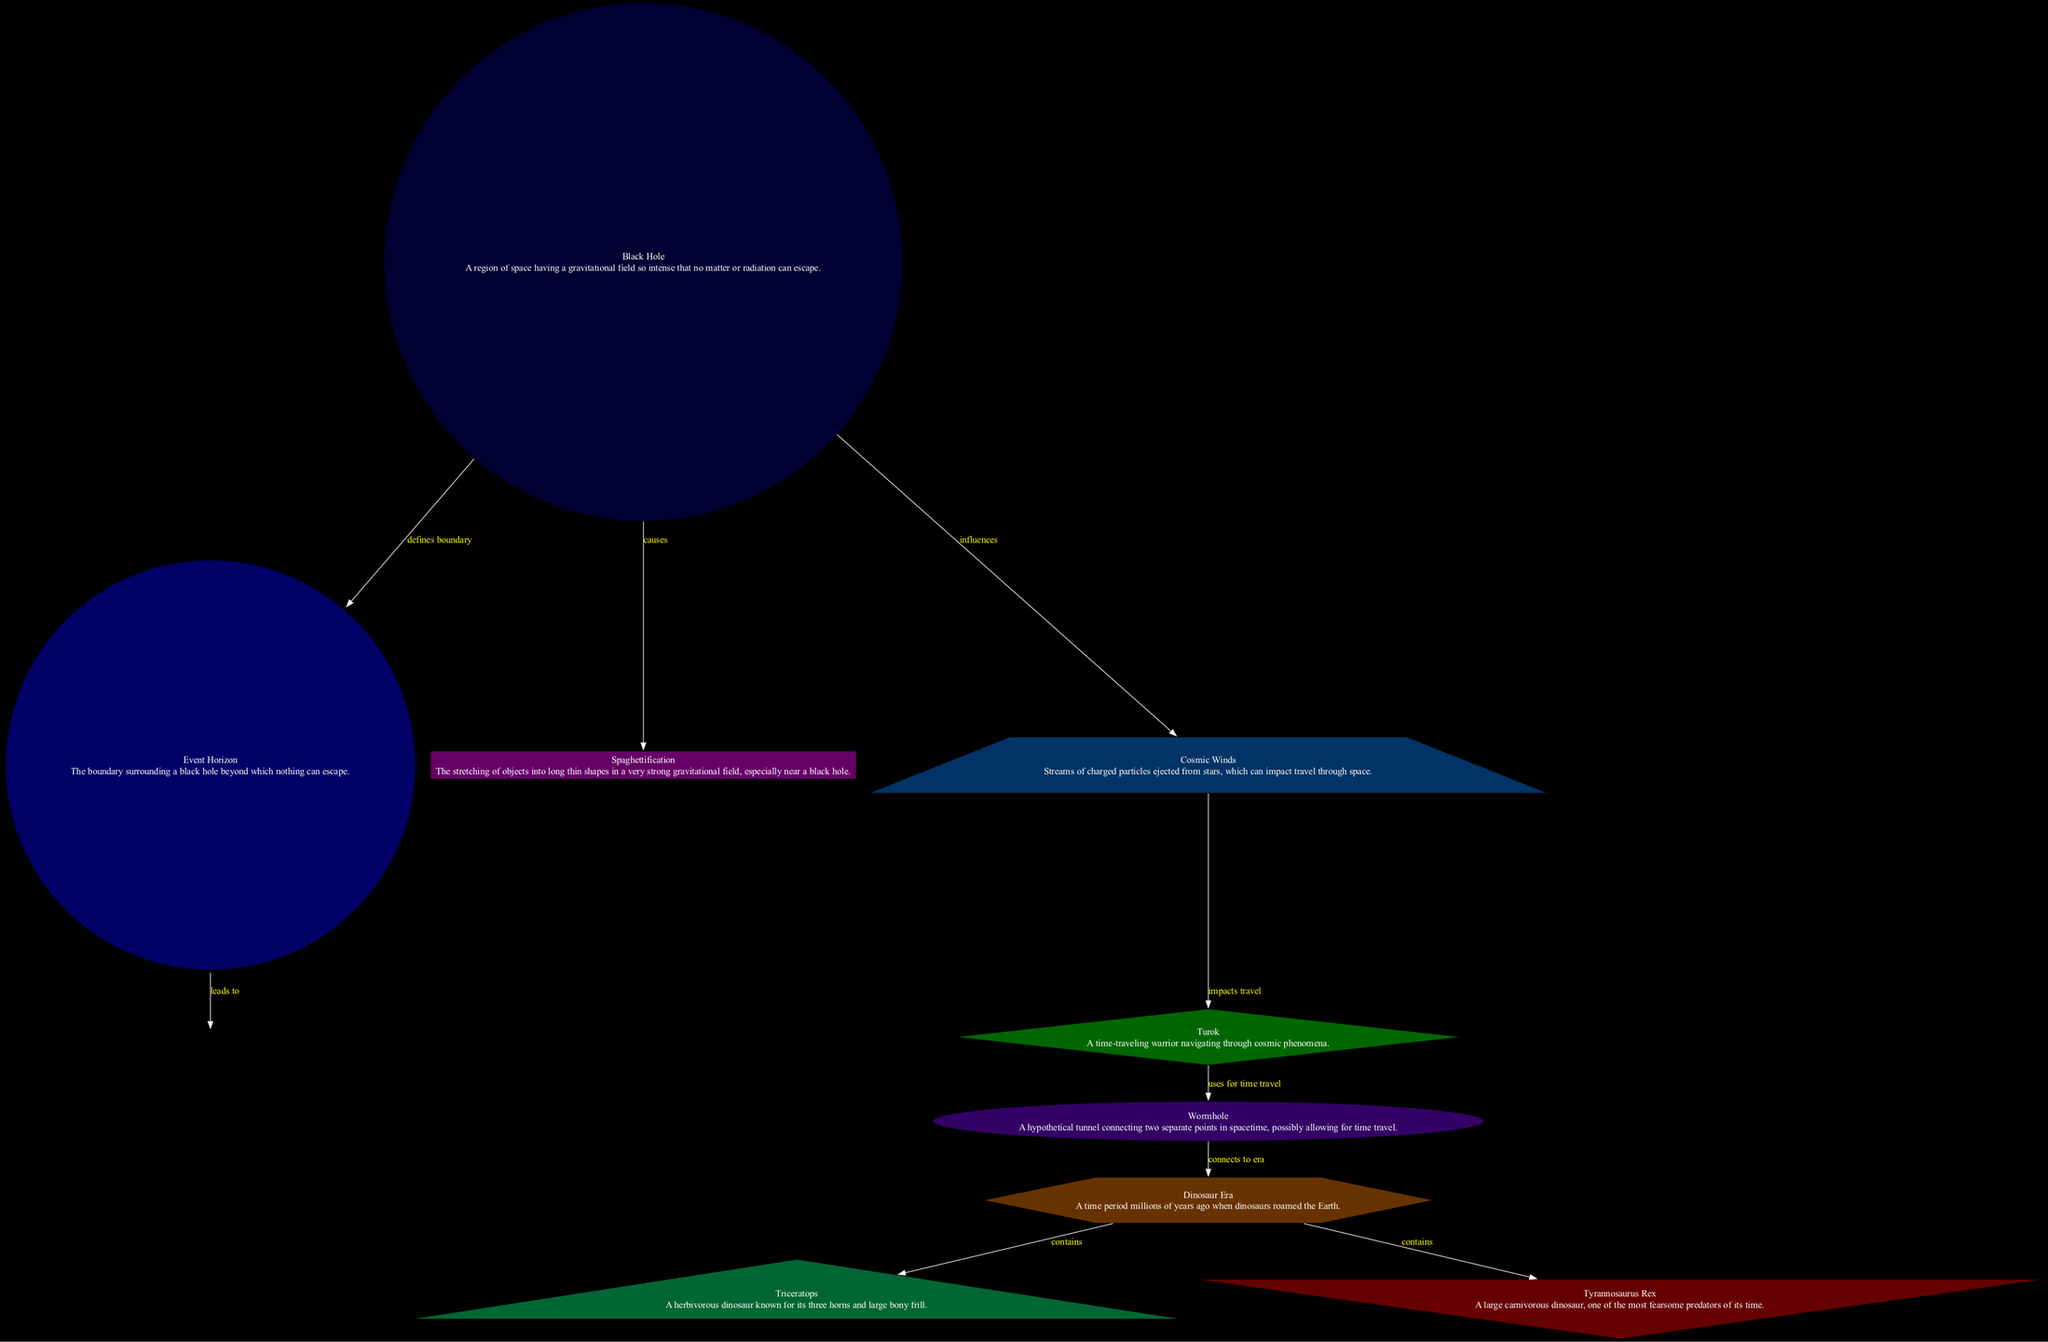What is the boundary surrounding a black hole called? The diagram indicates that the boundary surrounding a black hole is referred to as the "Event Horizon." This is the first piece of information associated with the black hole node in the diagram.
Answer: Event Horizon What dinosaur is known for its three horns? According to the diagram, the "Triceratops" is identified as a herbivorous dinosaur known for its three horns. This description is directly provided under the triceratops node.
Answer: Triceratops How many nodes are there in the diagram? The diagram contains a total of 10 nodes listed under the nodes section: black hole, event horizon, singularity, spaghettification, turok, wormhole, dinosaur era, triceratops, tyrannosaurus rex, and cosmic winds. Counting these gives us the total of 10 nodes.
Answer: 10 What effect does a black hole have on objects approaching it? The diagram states that a black hole causes "spaghettification," which is the stretching of objects into long thin shapes in a strong gravitational field. This relationship is specifically stated in the edge leading from black hole to spaghettification.
Answer: Spaghettification What connects Turok to the Dinosaur Era? The diagram shows that the "wormhole" connects Turok to the Dinosaur Era. This connection is highlighted as a direct relationship between the two nodes in the diagram.
Answer: Wormhole Which dinosaur is described as a large carnivorous predator? The diagram specifies that the "Tyrannosaurus Rex" is a large carnivorous dinosaur, known for being one of the most fearsome predators during the Dinosaur Era. This information is presented under the tyrannosaurus rex node.
Answer: Tyrannosaurus Rex How do cosmic winds impact Turok? The diagram indicates that "cosmic winds" impact Turok's travel. The edge connecting cosmic winds to Turok is labeled as "impacts travel," thus directly linking these two elements.
Answer: Impacts travel What is the point of infinite gravity within a black hole called? Within the diagram, the point where gravity is infinitely strong and spacetime curves infinitely is referred to as the "Singularity." This is detailed in the description found under the singularity node.
Answer: Singularity What travel method does Turok use to navigate between different eras? The diagram indicates that Turok uses a "wormhole" for time travel, specifying that this is how he navigates through different periods in time, including the Dinosaur Era.
Answer: Wormhole 